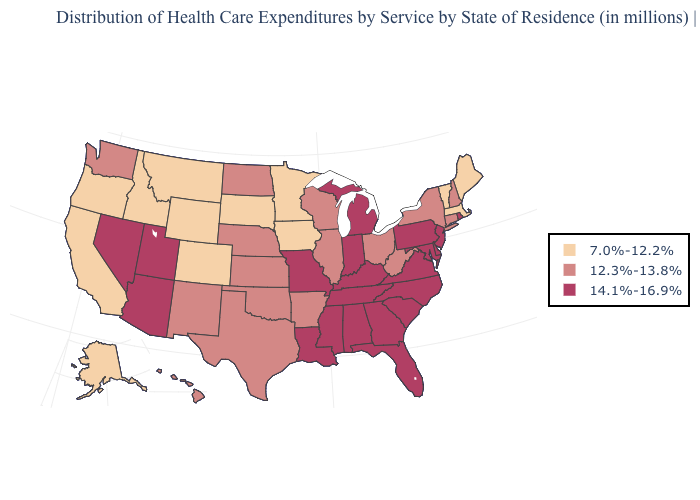Does the map have missing data?
Short answer required. No. What is the value of Wisconsin?
Keep it brief. 12.3%-13.8%. What is the value of Georgia?
Answer briefly. 14.1%-16.9%. Does Missouri have the lowest value in the USA?
Give a very brief answer. No. Among the states that border New Mexico , which have the lowest value?
Give a very brief answer. Colorado. Name the states that have a value in the range 12.3%-13.8%?
Quick response, please. Arkansas, Connecticut, Hawaii, Illinois, Kansas, Nebraska, New Hampshire, New Mexico, New York, North Dakota, Ohio, Oklahoma, Texas, Washington, West Virginia, Wisconsin. What is the value of Washington?
Concise answer only. 12.3%-13.8%. What is the highest value in states that border Virginia?
Keep it brief. 14.1%-16.9%. Does the map have missing data?
Give a very brief answer. No. What is the value of Vermont?
Answer briefly. 7.0%-12.2%. Does Alaska have the highest value in the West?
Keep it brief. No. Which states have the lowest value in the USA?
Concise answer only. Alaska, California, Colorado, Idaho, Iowa, Maine, Massachusetts, Minnesota, Montana, Oregon, South Dakota, Vermont, Wyoming. What is the value of Washington?
Answer briefly. 12.3%-13.8%. What is the value of Iowa?
Be succinct. 7.0%-12.2%. Does Ohio have the same value as Indiana?
Answer briefly. No. 